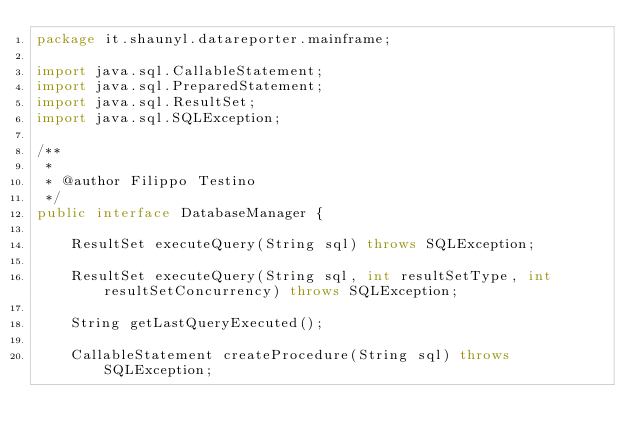Convert code to text. <code><loc_0><loc_0><loc_500><loc_500><_Java_>package it.shaunyl.datareporter.mainframe;

import java.sql.CallableStatement;
import java.sql.PreparedStatement;
import java.sql.ResultSet;
import java.sql.SQLException;

/**
 *
 * @author Filippo Testino
 */
public interface DatabaseManager {

    ResultSet executeQuery(String sql) throws SQLException;

    ResultSet executeQuery(String sql, int resultSetType, int resultSetConcurrency) throws SQLException;

    String getLastQueryExecuted();

    CallableStatement createProcedure(String sql) throws SQLException;
    </code> 